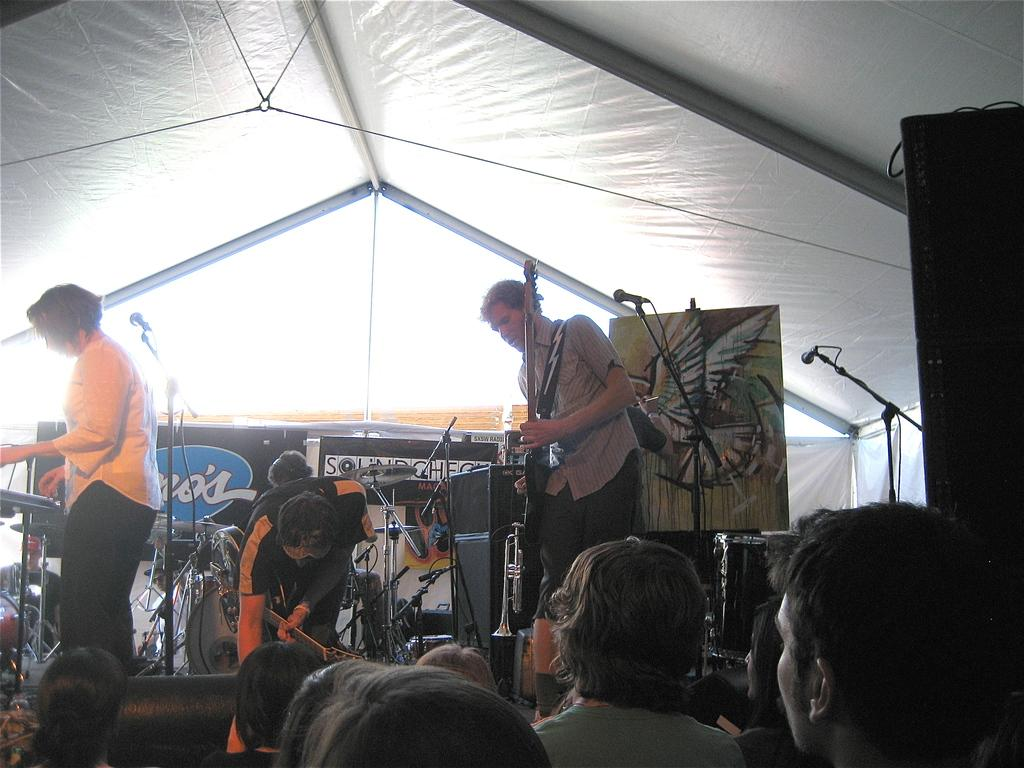What is happening in the image? There is a group of people in the image. Where are the people located? The people are standing on a stage. What are the people holding? The people are holding microphones. What are the people doing with the musical instruments? The people are playing musical instruments. What type of corn can be seen growing on the island in the image? There is no corn or island present in the image; it features a group of people on a stage playing musical instruments and holding microphones. 